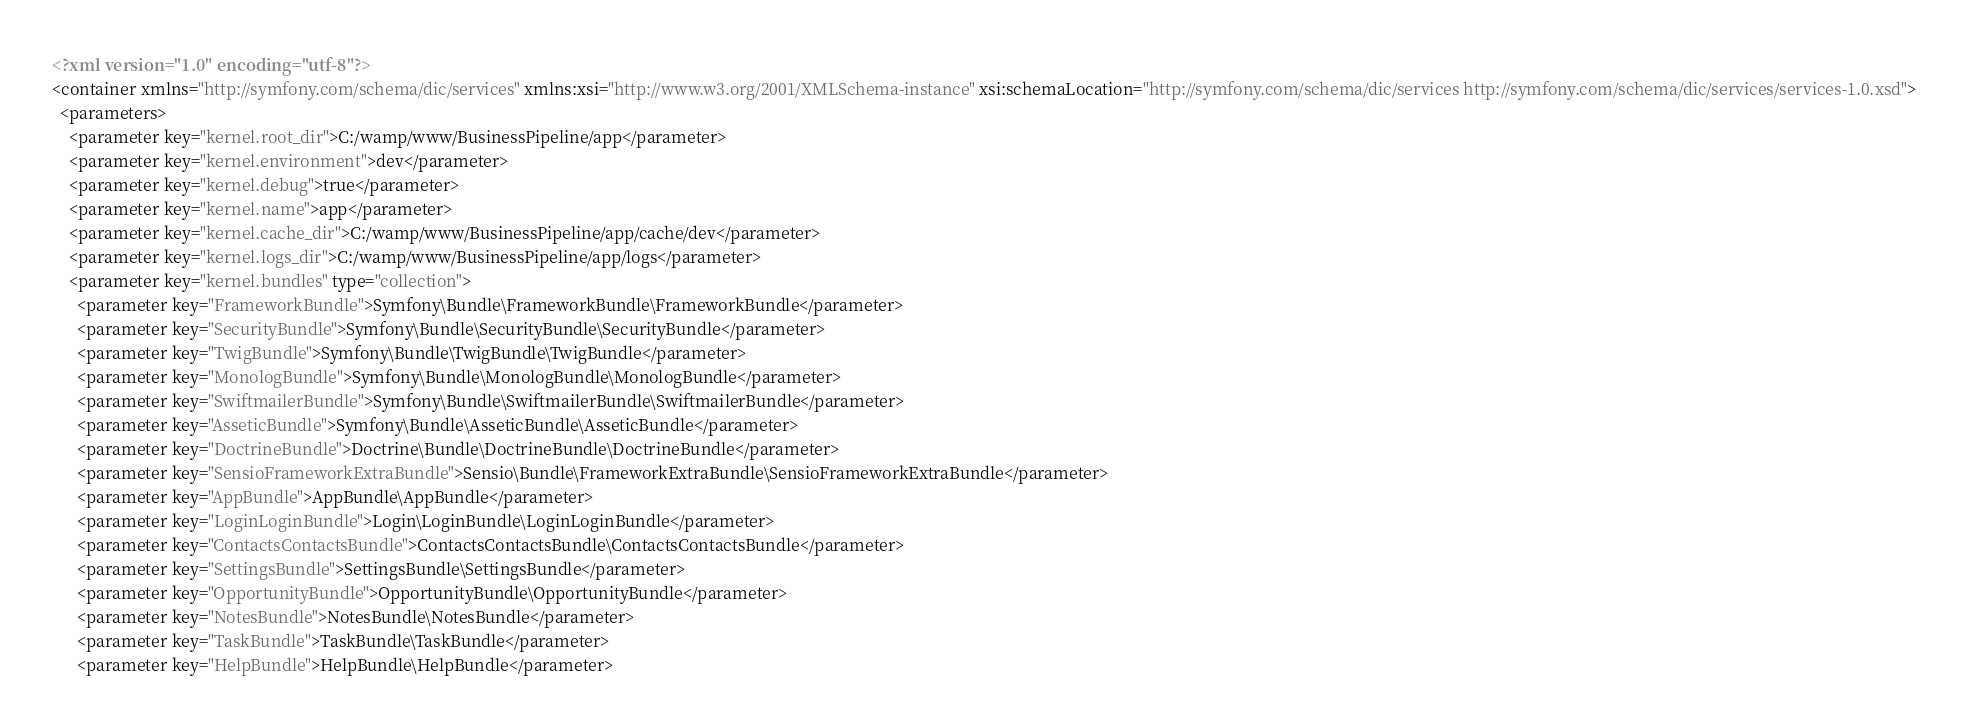<code> <loc_0><loc_0><loc_500><loc_500><_XML_><?xml version="1.0" encoding="utf-8"?>
<container xmlns="http://symfony.com/schema/dic/services" xmlns:xsi="http://www.w3.org/2001/XMLSchema-instance" xsi:schemaLocation="http://symfony.com/schema/dic/services http://symfony.com/schema/dic/services/services-1.0.xsd">
  <parameters>
    <parameter key="kernel.root_dir">C:/wamp/www/BusinessPipeline/app</parameter>
    <parameter key="kernel.environment">dev</parameter>
    <parameter key="kernel.debug">true</parameter>
    <parameter key="kernel.name">app</parameter>
    <parameter key="kernel.cache_dir">C:/wamp/www/BusinessPipeline/app/cache/dev</parameter>
    <parameter key="kernel.logs_dir">C:/wamp/www/BusinessPipeline/app/logs</parameter>
    <parameter key="kernel.bundles" type="collection">
      <parameter key="FrameworkBundle">Symfony\Bundle\FrameworkBundle\FrameworkBundle</parameter>
      <parameter key="SecurityBundle">Symfony\Bundle\SecurityBundle\SecurityBundle</parameter>
      <parameter key="TwigBundle">Symfony\Bundle\TwigBundle\TwigBundle</parameter>
      <parameter key="MonologBundle">Symfony\Bundle\MonologBundle\MonologBundle</parameter>
      <parameter key="SwiftmailerBundle">Symfony\Bundle\SwiftmailerBundle\SwiftmailerBundle</parameter>
      <parameter key="AsseticBundle">Symfony\Bundle\AsseticBundle\AsseticBundle</parameter>
      <parameter key="DoctrineBundle">Doctrine\Bundle\DoctrineBundle\DoctrineBundle</parameter>
      <parameter key="SensioFrameworkExtraBundle">Sensio\Bundle\FrameworkExtraBundle\SensioFrameworkExtraBundle</parameter>
      <parameter key="AppBundle">AppBundle\AppBundle</parameter>
      <parameter key="LoginLoginBundle">Login\LoginBundle\LoginLoginBundle</parameter>
      <parameter key="ContactsContactsBundle">ContactsContactsBundle\ContactsContactsBundle</parameter>
      <parameter key="SettingsBundle">SettingsBundle\SettingsBundle</parameter>
      <parameter key="OpportunityBundle">OpportunityBundle\OpportunityBundle</parameter>
      <parameter key="NotesBundle">NotesBundle\NotesBundle</parameter>
      <parameter key="TaskBundle">TaskBundle\TaskBundle</parameter>
      <parameter key="HelpBundle">HelpBundle\HelpBundle</parameter></code> 